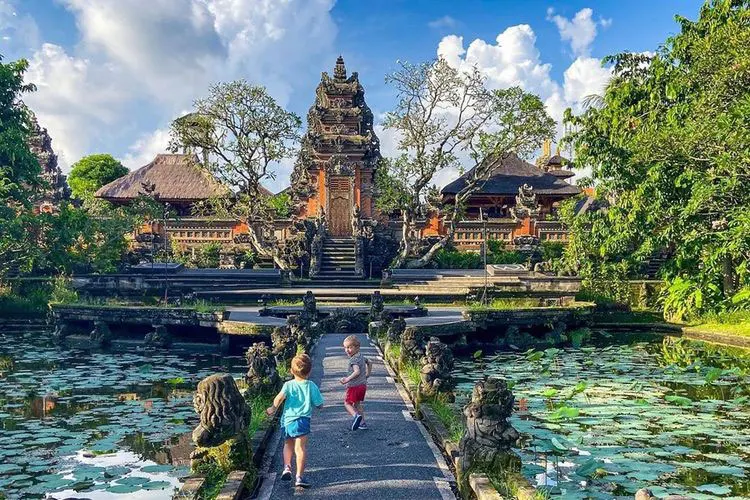What are the key elements in this picture? The image beautifully captures the Ubud Water Palace in Bali, Indonesia, a testament to architectural elegance and natural splendor. The striking red-brick palace emerges prominently, showcasing intricate carvings and statues that embody the area's rich cultural heritage. Surrounded by a lush array of greenery, the palace is bordered by a large pond filled with serene lily pads, enhancing the tranquil atmosphere. In the foreground, two children walking along a path add a sense of scale and life to the scene, giving viewers a vivid sense of the grandeur and serenity that the Ubud Water Palace offers. 